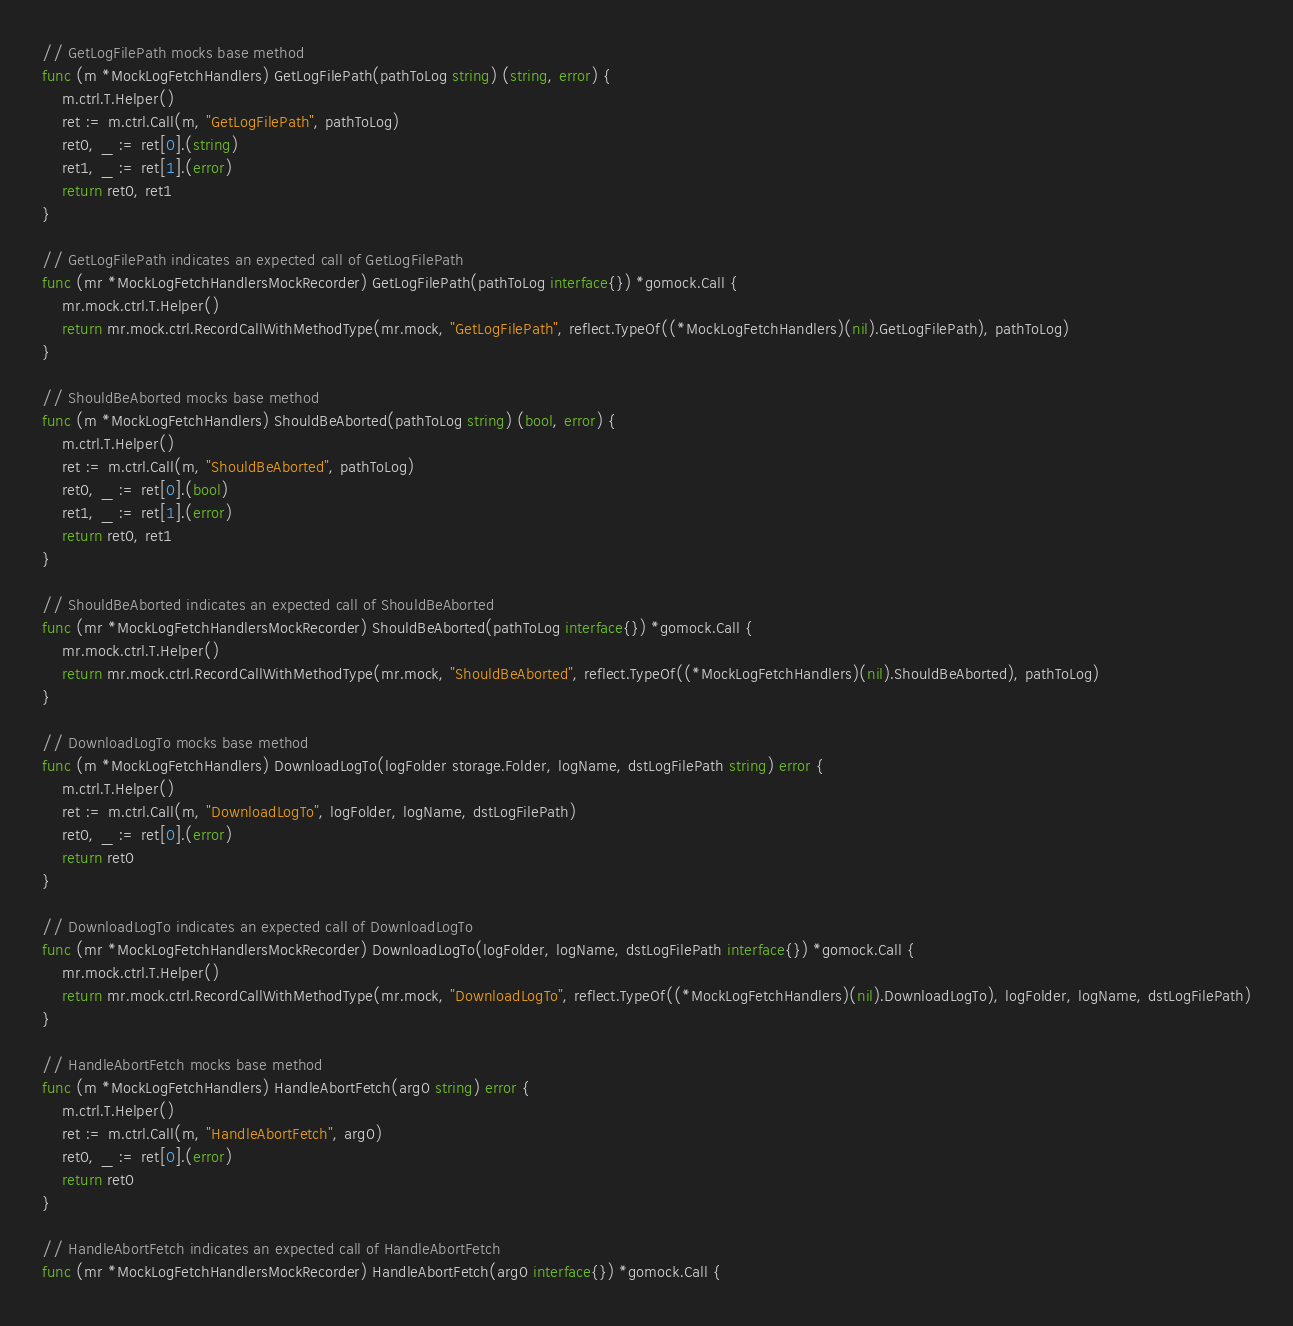<code> <loc_0><loc_0><loc_500><loc_500><_Go_>// GetLogFilePath mocks base method
func (m *MockLogFetchHandlers) GetLogFilePath(pathToLog string) (string, error) {
	m.ctrl.T.Helper()
	ret := m.ctrl.Call(m, "GetLogFilePath", pathToLog)
	ret0, _ := ret[0].(string)
	ret1, _ := ret[1].(error)
	return ret0, ret1
}

// GetLogFilePath indicates an expected call of GetLogFilePath
func (mr *MockLogFetchHandlersMockRecorder) GetLogFilePath(pathToLog interface{}) *gomock.Call {
	mr.mock.ctrl.T.Helper()
	return mr.mock.ctrl.RecordCallWithMethodType(mr.mock, "GetLogFilePath", reflect.TypeOf((*MockLogFetchHandlers)(nil).GetLogFilePath), pathToLog)
}

// ShouldBeAborted mocks base method
func (m *MockLogFetchHandlers) ShouldBeAborted(pathToLog string) (bool, error) {
	m.ctrl.T.Helper()
	ret := m.ctrl.Call(m, "ShouldBeAborted", pathToLog)
	ret0, _ := ret[0].(bool)
	ret1, _ := ret[1].(error)
	return ret0, ret1
}

// ShouldBeAborted indicates an expected call of ShouldBeAborted
func (mr *MockLogFetchHandlersMockRecorder) ShouldBeAborted(pathToLog interface{}) *gomock.Call {
	mr.mock.ctrl.T.Helper()
	return mr.mock.ctrl.RecordCallWithMethodType(mr.mock, "ShouldBeAborted", reflect.TypeOf((*MockLogFetchHandlers)(nil).ShouldBeAborted), pathToLog)
}

// DownloadLogTo mocks base method
func (m *MockLogFetchHandlers) DownloadLogTo(logFolder storage.Folder, logName, dstLogFilePath string) error {
	m.ctrl.T.Helper()
	ret := m.ctrl.Call(m, "DownloadLogTo", logFolder, logName, dstLogFilePath)
	ret0, _ := ret[0].(error)
	return ret0
}

// DownloadLogTo indicates an expected call of DownloadLogTo
func (mr *MockLogFetchHandlersMockRecorder) DownloadLogTo(logFolder, logName, dstLogFilePath interface{}) *gomock.Call {
	mr.mock.ctrl.T.Helper()
	return mr.mock.ctrl.RecordCallWithMethodType(mr.mock, "DownloadLogTo", reflect.TypeOf((*MockLogFetchHandlers)(nil).DownloadLogTo), logFolder, logName, dstLogFilePath)
}

// HandleAbortFetch mocks base method
func (m *MockLogFetchHandlers) HandleAbortFetch(arg0 string) error {
	m.ctrl.T.Helper()
	ret := m.ctrl.Call(m, "HandleAbortFetch", arg0)
	ret0, _ := ret[0].(error)
	return ret0
}

// HandleAbortFetch indicates an expected call of HandleAbortFetch
func (mr *MockLogFetchHandlersMockRecorder) HandleAbortFetch(arg0 interface{}) *gomock.Call {</code> 